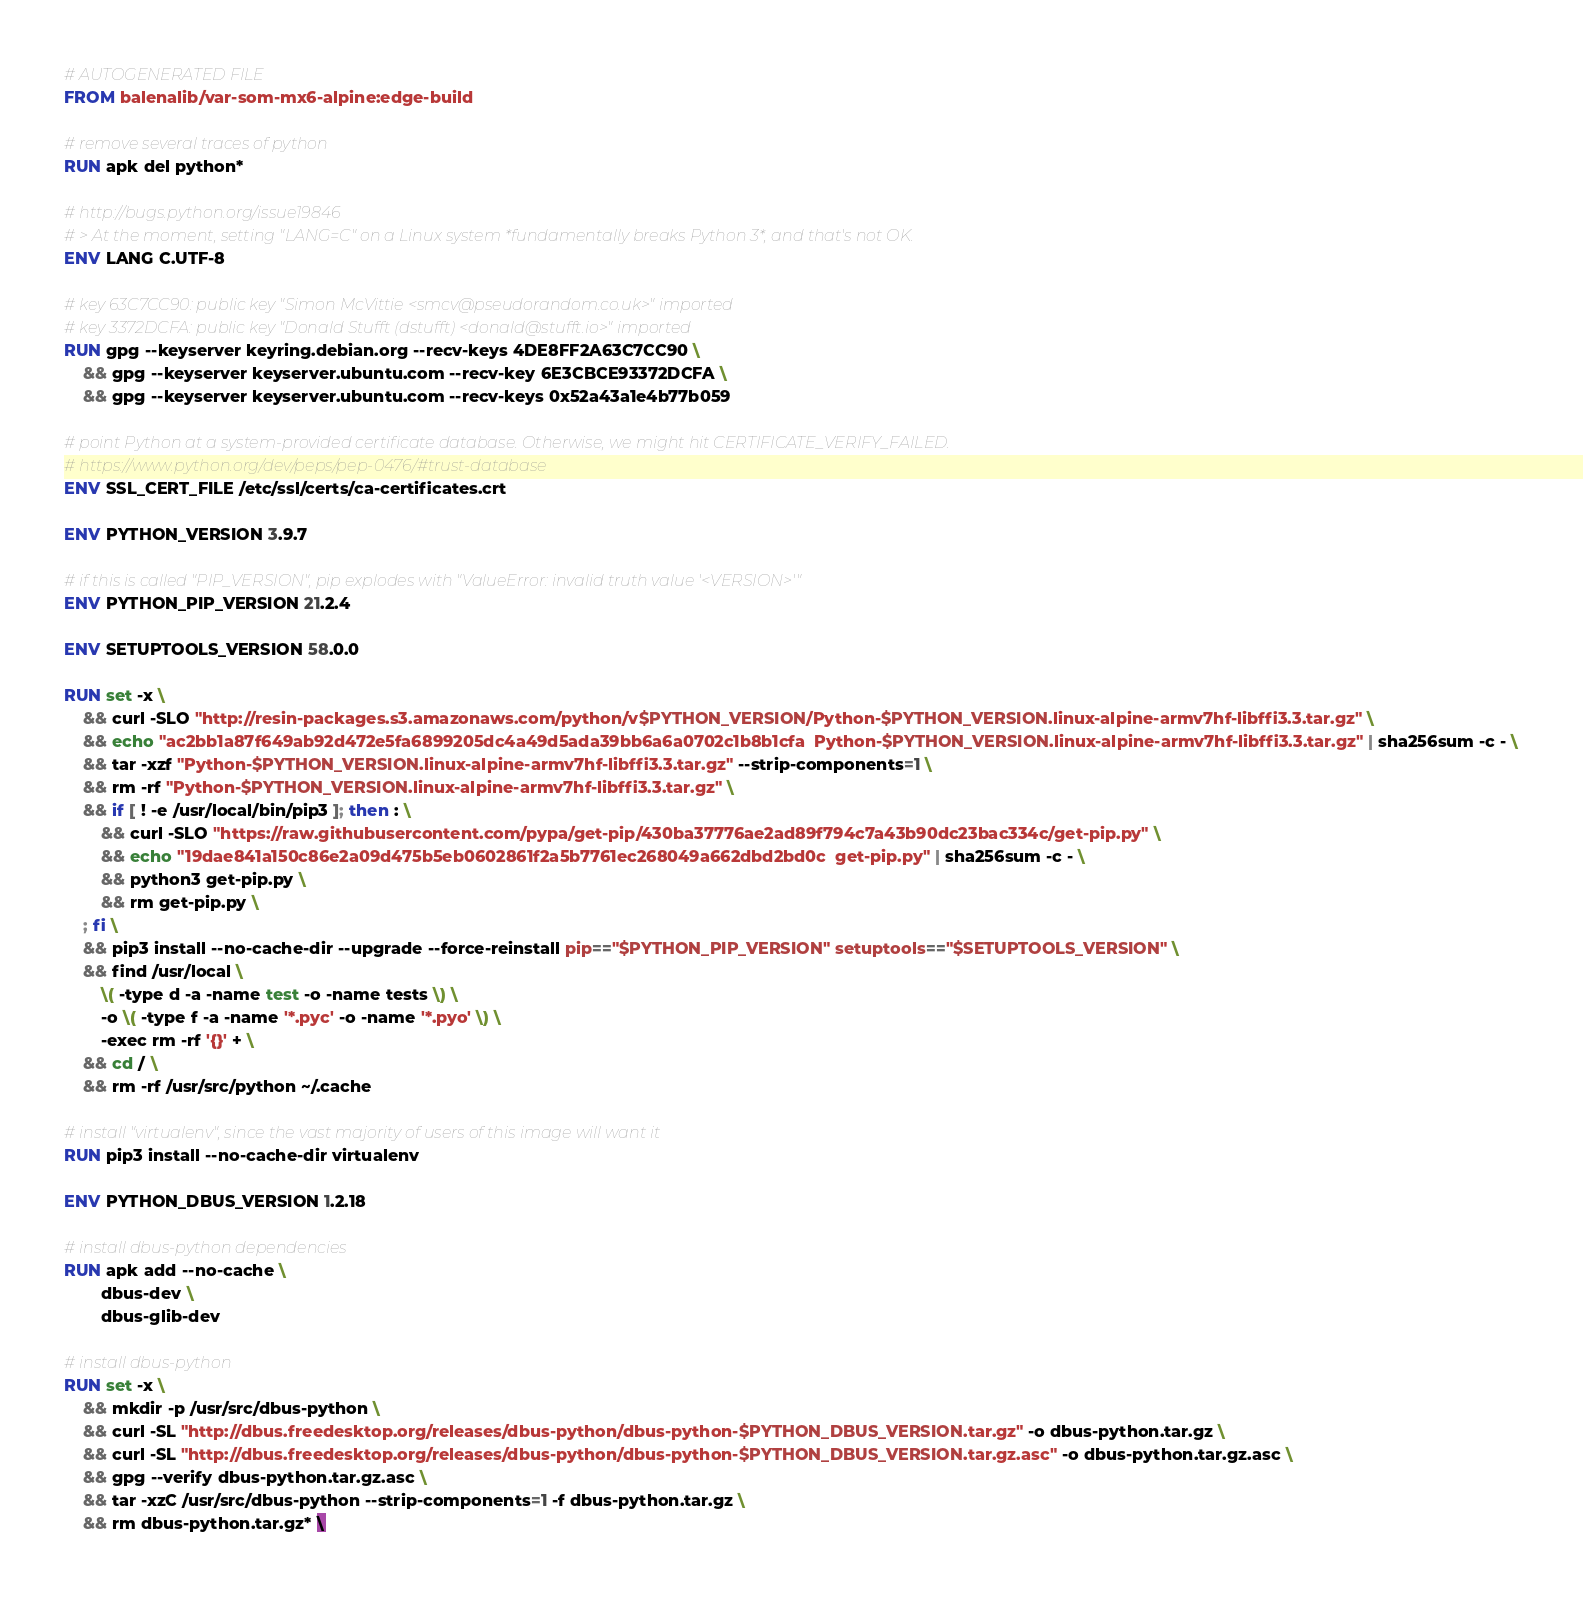Convert code to text. <code><loc_0><loc_0><loc_500><loc_500><_Dockerfile_># AUTOGENERATED FILE
FROM balenalib/var-som-mx6-alpine:edge-build

# remove several traces of python
RUN apk del python*

# http://bugs.python.org/issue19846
# > At the moment, setting "LANG=C" on a Linux system *fundamentally breaks Python 3*, and that's not OK.
ENV LANG C.UTF-8

# key 63C7CC90: public key "Simon McVittie <smcv@pseudorandom.co.uk>" imported
# key 3372DCFA: public key "Donald Stufft (dstufft) <donald@stufft.io>" imported
RUN gpg --keyserver keyring.debian.org --recv-keys 4DE8FF2A63C7CC90 \
	&& gpg --keyserver keyserver.ubuntu.com --recv-key 6E3CBCE93372DCFA \
	&& gpg --keyserver keyserver.ubuntu.com --recv-keys 0x52a43a1e4b77b059

# point Python at a system-provided certificate database. Otherwise, we might hit CERTIFICATE_VERIFY_FAILED.
# https://www.python.org/dev/peps/pep-0476/#trust-database
ENV SSL_CERT_FILE /etc/ssl/certs/ca-certificates.crt

ENV PYTHON_VERSION 3.9.7

# if this is called "PIP_VERSION", pip explodes with "ValueError: invalid truth value '<VERSION>'"
ENV PYTHON_PIP_VERSION 21.2.4

ENV SETUPTOOLS_VERSION 58.0.0

RUN set -x \
	&& curl -SLO "http://resin-packages.s3.amazonaws.com/python/v$PYTHON_VERSION/Python-$PYTHON_VERSION.linux-alpine-armv7hf-libffi3.3.tar.gz" \
	&& echo "ac2bb1a87f649ab92d472e5fa6899205dc4a49d5ada39bb6a6a0702c1b8b1cfa  Python-$PYTHON_VERSION.linux-alpine-armv7hf-libffi3.3.tar.gz" | sha256sum -c - \
	&& tar -xzf "Python-$PYTHON_VERSION.linux-alpine-armv7hf-libffi3.3.tar.gz" --strip-components=1 \
	&& rm -rf "Python-$PYTHON_VERSION.linux-alpine-armv7hf-libffi3.3.tar.gz" \
	&& if [ ! -e /usr/local/bin/pip3 ]; then : \
		&& curl -SLO "https://raw.githubusercontent.com/pypa/get-pip/430ba37776ae2ad89f794c7a43b90dc23bac334c/get-pip.py" \
		&& echo "19dae841a150c86e2a09d475b5eb0602861f2a5b7761ec268049a662dbd2bd0c  get-pip.py" | sha256sum -c - \
		&& python3 get-pip.py \
		&& rm get-pip.py \
	; fi \
	&& pip3 install --no-cache-dir --upgrade --force-reinstall pip=="$PYTHON_PIP_VERSION" setuptools=="$SETUPTOOLS_VERSION" \
	&& find /usr/local \
		\( -type d -a -name test -o -name tests \) \
		-o \( -type f -a -name '*.pyc' -o -name '*.pyo' \) \
		-exec rm -rf '{}' + \
	&& cd / \
	&& rm -rf /usr/src/python ~/.cache

# install "virtualenv", since the vast majority of users of this image will want it
RUN pip3 install --no-cache-dir virtualenv

ENV PYTHON_DBUS_VERSION 1.2.18

# install dbus-python dependencies 
RUN apk add --no-cache \
		dbus-dev \
		dbus-glib-dev

# install dbus-python
RUN set -x \
	&& mkdir -p /usr/src/dbus-python \
	&& curl -SL "http://dbus.freedesktop.org/releases/dbus-python/dbus-python-$PYTHON_DBUS_VERSION.tar.gz" -o dbus-python.tar.gz \
	&& curl -SL "http://dbus.freedesktop.org/releases/dbus-python/dbus-python-$PYTHON_DBUS_VERSION.tar.gz.asc" -o dbus-python.tar.gz.asc \
	&& gpg --verify dbus-python.tar.gz.asc \
	&& tar -xzC /usr/src/dbus-python --strip-components=1 -f dbus-python.tar.gz \
	&& rm dbus-python.tar.gz* \</code> 